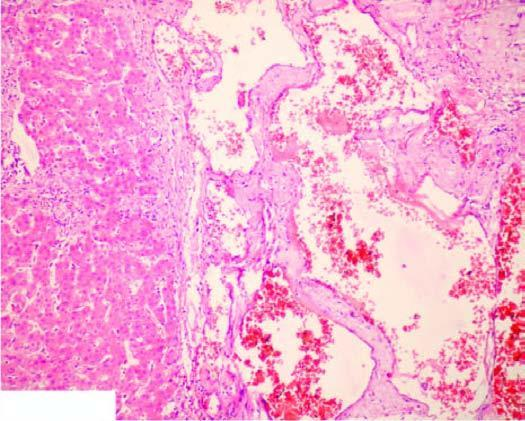what are large, dilated, many containing blood, and are lined by flattened endothelial cells?
Answer the question using a single word or phrase. Vascular spaces 